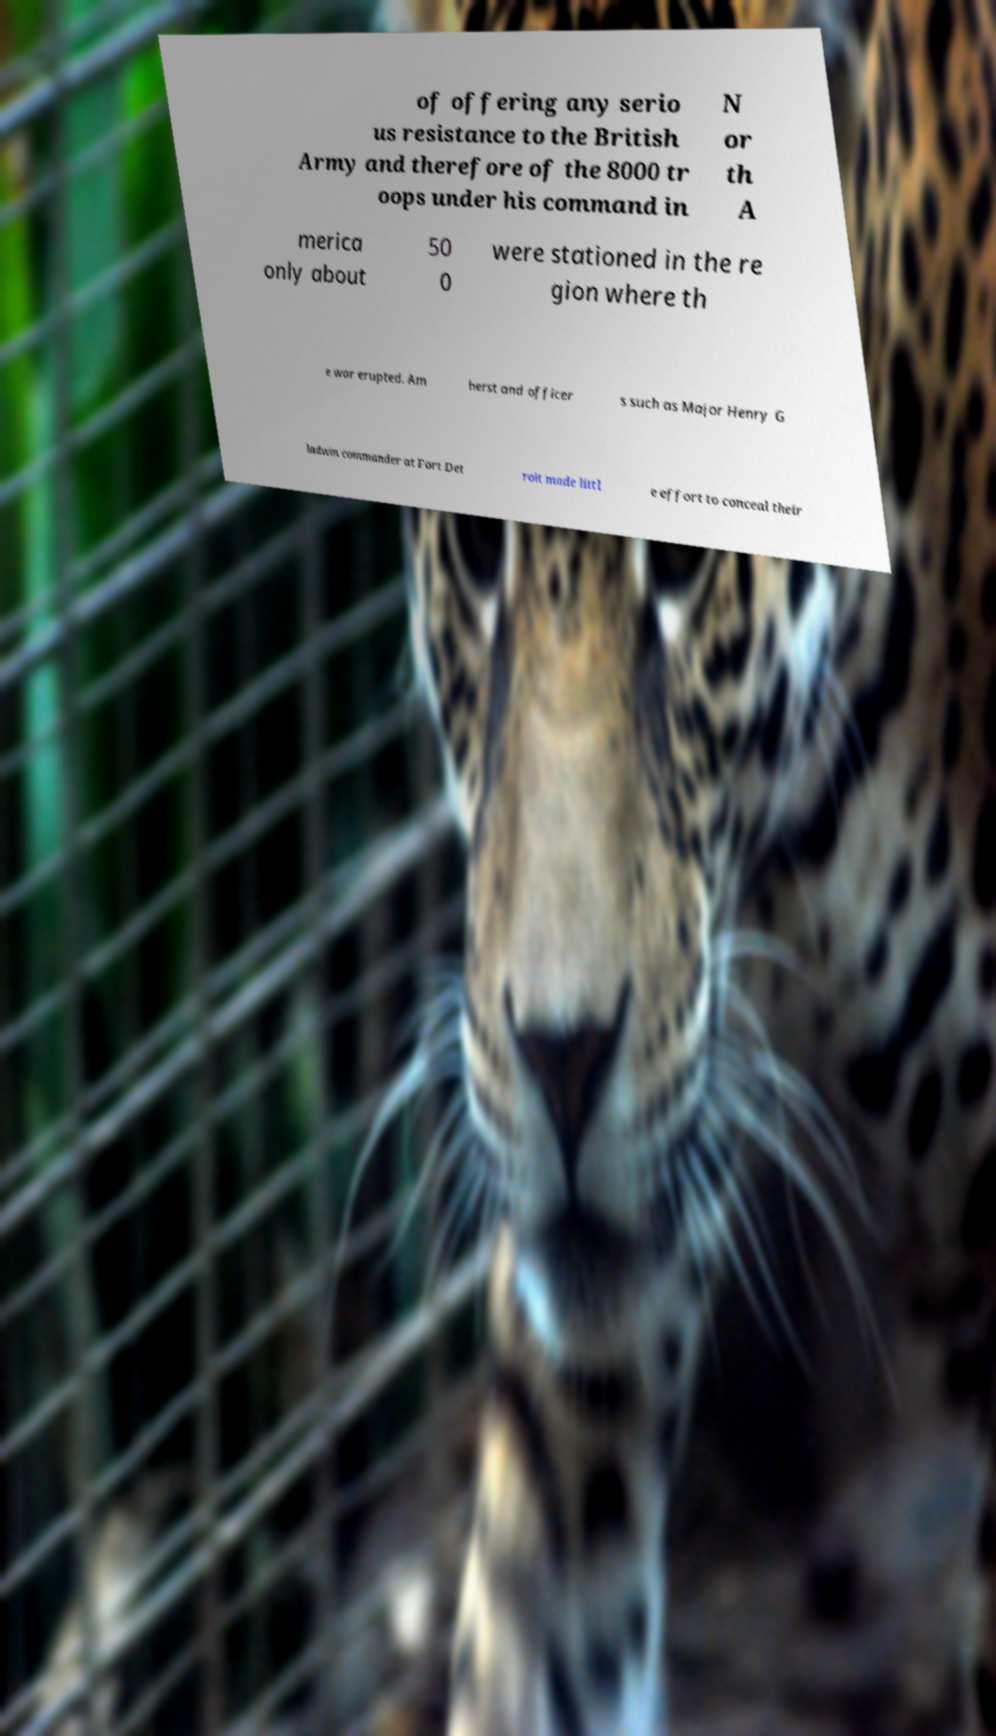Please identify and transcribe the text found in this image. of offering any serio us resistance to the British Army and therefore of the 8000 tr oops under his command in N or th A merica only about 50 0 were stationed in the re gion where th e war erupted. Am herst and officer s such as Major Henry G ladwin commander at Fort Det roit made littl e effort to conceal their 